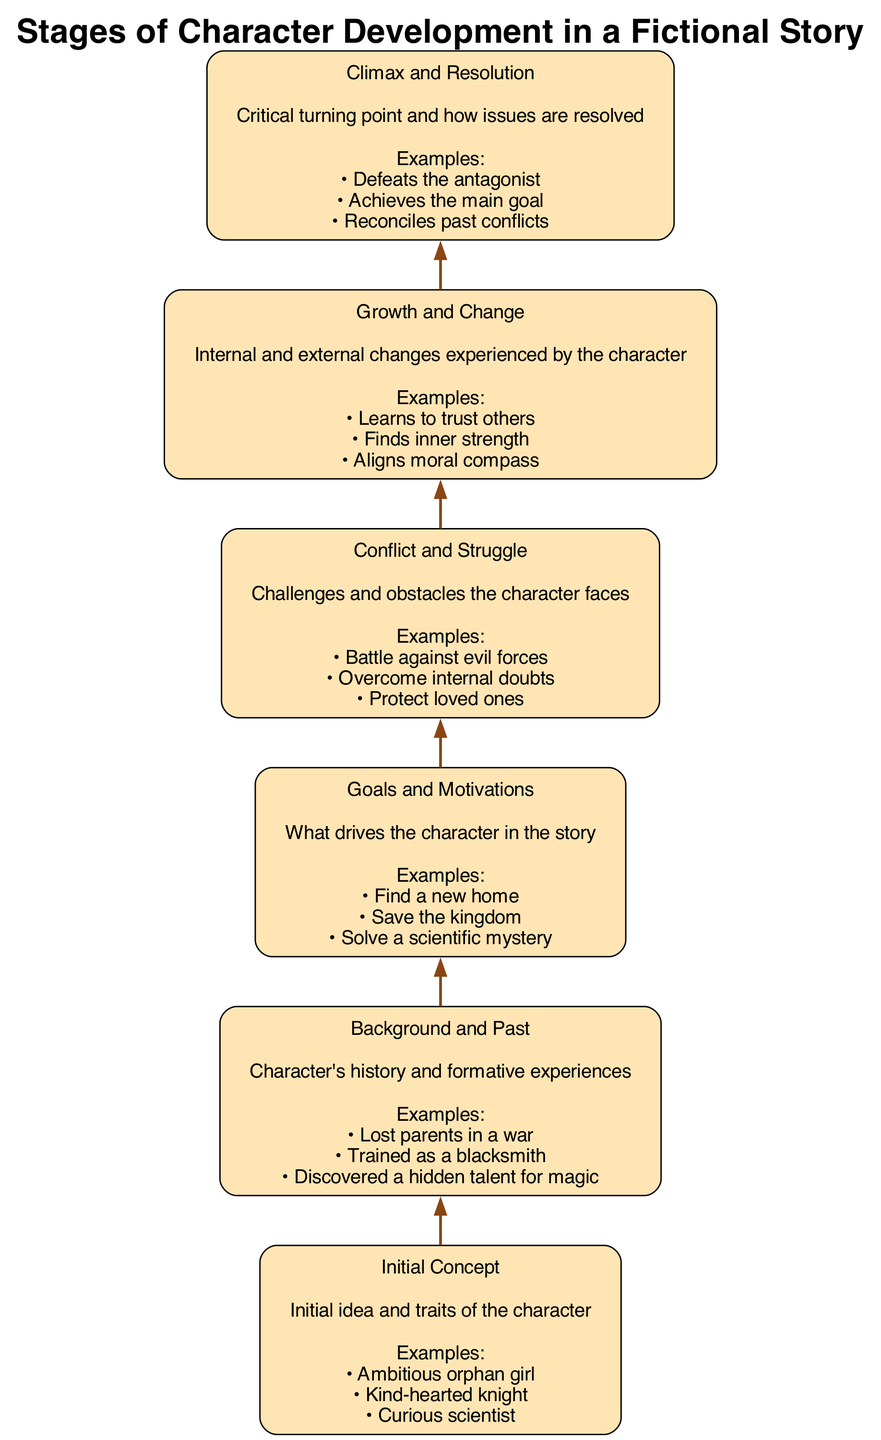What is the first stage of character development? The first stage listed in the diagram is "Initial Concept," which introduces the character's initial idea and traits.
Answer: Initial Concept How many examples are provided for the "Conflict and Struggle" stage? The "Conflict and Struggle" stage lists three examples: "Battle against evil forces," "Overcome internal doubts," and "Protect loved ones," which is a total of three.
Answer: 3 Which stage directly precedes "Climax and Resolution"? The stage that comes directly before "Climax and Resolution" in the flow is "Growth and Change," indicating it leads into the climax and resolution of the character's journey.
Answer: Growth and Change What do characters experience in the "Growth and Change" stage? In this stage, characters undergo internal and external changes, such as learning to trust others or finding inner strength.
Answer: Internal and external changes How many stages are depicted in the diagram? The diagram consists of six distinct stages, outlining the full process of character development in a fictional story.
Answer: 6 Which stage focuses on the character's history? The stage that emphasizes the character's history and formative experiences is "Background and Past." This includes significant events that shape the character.
Answer: Background and Past What character trait is exemplified in the "Initial Concept" stage? The "Initial Concept" stage may illustrate a character trait such as "Ambitious," represented in various initial concepts provided.
Answer: Ambitious What type of obstacles are addressed in the "Conflict and Struggle" stage? This stage deals with challenges and obstacles such as battling evil forces and overcoming internal doubts that confront the character.
Answer: Challenges and obstacles What is the main focus of the "Goals and Motivations" stage? The "Goals and Motivations" stage highlights what drives the character in the story, such as finding a new home or saving the kingdom.
Answer: Character's drives 